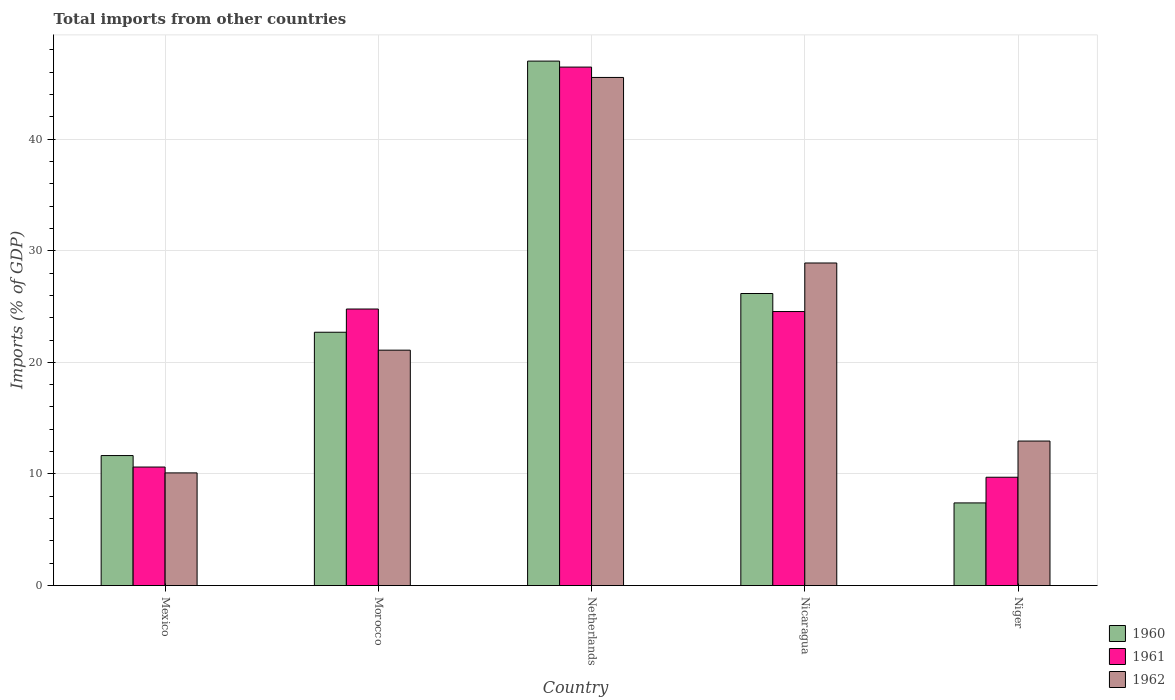How many bars are there on the 4th tick from the left?
Provide a succinct answer. 3. What is the label of the 3rd group of bars from the left?
Ensure brevity in your answer.  Netherlands. What is the total imports in 1961 in Netherlands?
Offer a very short reply. 46.46. Across all countries, what is the maximum total imports in 1961?
Make the answer very short. 46.46. Across all countries, what is the minimum total imports in 1961?
Keep it short and to the point. 9.71. What is the total total imports in 1962 in the graph?
Make the answer very short. 118.57. What is the difference between the total imports in 1960 in Nicaragua and that in Niger?
Provide a short and direct response. 18.76. What is the difference between the total imports in 1960 in Mexico and the total imports in 1962 in Niger?
Keep it short and to the point. -1.3. What is the average total imports in 1962 per country?
Offer a terse response. 23.71. What is the difference between the total imports of/in 1962 and total imports of/in 1961 in Netherlands?
Keep it short and to the point. -0.93. In how many countries, is the total imports in 1960 greater than 12 %?
Keep it short and to the point. 3. What is the ratio of the total imports in 1962 in Morocco to that in Nicaragua?
Provide a succinct answer. 0.73. What is the difference between the highest and the second highest total imports in 1962?
Your answer should be compact. -7.81. What is the difference between the highest and the lowest total imports in 1961?
Give a very brief answer. 36.75. Is the sum of the total imports in 1962 in Morocco and Niger greater than the maximum total imports in 1961 across all countries?
Make the answer very short. No. How many bars are there?
Provide a succinct answer. 15. Are the values on the major ticks of Y-axis written in scientific E-notation?
Your response must be concise. No. Does the graph contain any zero values?
Offer a terse response. No. Does the graph contain grids?
Your answer should be very brief. Yes. How many legend labels are there?
Provide a succinct answer. 3. How are the legend labels stacked?
Provide a succinct answer. Vertical. What is the title of the graph?
Your response must be concise. Total imports from other countries. What is the label or title of the X-axis?
Offer a very short reply. Country. What is the label or title of the Y-axis?
Your answer should be compact. Imports (% of GDP). What is the Imports (% of GDP) in 1960 in Mexico?
Provide a succinct answer. 11.65. What is the Imports (% of GDP) of 1961 in Mexico?
Your answer should be very brief. 10.62. What is the Imports (% of GDP) in 1962 in Mexico?
Offer a very short reply. 10.09. What is the Imports (% of GDP) of 1960 in Morocco?
Offer a very short reply. 22.7. What is the Imports (% of GDP) in 1961 in Morocco?
Ensure brevity in your answer.  24.78. What is the Imports (% of GDP) of 1962 in Morocco?
Provide a short and direct response. 21.09. What is the Imports (% of GDP) in 1960 in Netherlands?
Ensure brevity in your answer.  46.99. What is the Imports (% of GDP) of 1961 in Netherlands?
Provide a succinct answer. 46.46. What is the Imports (% of GDP) in 1962 in Netherlands?
Provide a short and direct response. 45.53. What is the Imports (% of GDP) of 1960 in Nicaragua?
Your answer should be very brief. 26.17. What is the Imports (% of GDP) of 1961 in Nicaragua?
Keep it short and to the point. 24.55. What is the Imports (% of GDP) of 1962 in Nicaragua?
Your answer should be very brief. 28.9. What is the Imports (% of GDP) of 1960 in Niger?
Offer a very short reply. 7.41. What is the Imports (% of GDP) of 1961 in Niger?
Offer a terse response. 9.71. What is the Imports (% of GDP) of 1962 in Niger?
Your response must be concise. 12.95. Across all countries, what is the maximum Imports (% of GDP) of 1960?
Offer a terse response. 46.99. Across all countries, what is the maximum Imports (% of GDP) of 1961?
Offer a terse response. 46.46. Across all countries, what is the maximum Imports (% of GDP) of 1962?
Keep it short and to the point. 45.53. Across all countries, what is the minimum Imports (% of GDP) in 1960?
Offer a terse response. 7.41. Across all countries, what is the minimum Imports (% of GDP) of 1961?
Keep it short and to the point. 9.71. Across all countries, what is the minimum Imports (% of GDP) in 1962?
Make the answer very short. 10.09. What is the total Imports (% of GDP) of 1960 in the graph?
Provide a succinct answer. 114.92. What is the total Imports (% of GDP) of 1961 in the graph?
Give a very brief answer. 116.11. What is the total Imports (% of GDP) in 1962 in the graph?
Offer a very short reply. 118.57. What is the difference between the Imports (% of GDP) of 1960 in Mexico and that in Morocco?
Ensure brevity in your answer.  -11.05. What is the difference between the Imports (% of GDP) in 1961 in Mexico and that in Morocco?
Your answer should be very brief. -14.16. What is the difference between the Imports (% of GDP) of 1962 in Mexico and that in Morocco?
Your response must be concise. -11. What is the difference between the Imports (% of GDP) in 1960 in Mexico and that in Netherlands?
Give a very brief answer. -35.34. What is the difference between the Imports (% of GDP) in 1961 in Mexico and that in Netherlands?
Your answer should be very brief. -35.84. What is the difference between the Imports (% of GDP) in 1962 in Mexico and that in Netherlands?
Offer a terse response. -35.43. What is the difference between the Imports (% of GDP) of 1960 in Mexico and that in Nicaragua?
Keep it short and to the point. -14.52. What is the difference between the Imports (% of GDP) of 1961 in Mexico and that in Nicaragua?
Provide a short and direct response. -13.93. What is the difference between the Imports (% of GDP) of 1962 in Mexico and that in Nicaragua?
Your answer should be very brief. -18.81. What is the difference between the Imports (% of GDP) of 1960 in Mexico and that in Niger?
Your answer should be very brief. 4.24. What is the difference between the Imports (% of GDP) in 1961 in Mexico and that in Niger?
Provide a succinct answer. 0.91. What is the difference between the Imports (% of GDP) in 1962 in Mexico and that in Niger?
Provide a short and direct response. -2.85. What is the difference between the Imports (% of GDP) of 1960 in Morocco and that in Netherlands?
Your answer should be very brief. -24.29. What is the difference between the Imports (% of GDP) in 1961 in Morocco and that in Netherlands?
Your answer should be compact. -21.68. What is the difference between the Imports (% of GDP) in 1962 in Morocco and that in Netherlands?
Make the answer very short. -24.44. What is the difference between the Imports (% of GDP) in 1960 in Morocco and that in Nicaragua?
Offer a terse response. -3.47. What is the difference between the Imports (% of GDP) of 1961 in Morocco and that in Nicaragua?
Ensure brevity in your answer.  0.22. What is the difference between the Imports (% of GDP) in 1962 in Morocco and that in Nicaragua?
Make the answer very short. -7.81. What is the difference between the Imports (% of GDP) of 1960 in Morocco and that in Niger?
Your response must be concise. 15.29. What is the difference between the Imports (% of GDP) in 1961 in Morocco and that in Niger?
Your answer should be very brief. 15.07. What is the difference between the Imports (% of GDP) in 1962 in Morocco and that in Niger?
Ensure brevity in your answer.  8.15. What is the difference between the Imports (% of GDP) in 1960 in Netherlands and that in Nicaragua?
Provide a succinct answer. 20.82. What is the difference between the Imports (% of GDP) in 1961 in Netherlands and that in Nicaragua?
Provide a succinct answer. 21.9. What is the difference between the Imports (% of GDP) in 1962 in Netherlands and that in Nicaragua?
Your answer should be very brief. 16.63. What is the difference between the Imports (% of GDP) in 1960 in Netherlands and that in Niger?
Provide a short and direct response. 39.59. What is the difference between the Imports (% of GDP) in 1961 in Netherlands and that in Niger?
Make the answer very short. 36.75. What is the difference between the Imports (% of GDP) of 1962 in Netherlands and that in Niger?
Your answer should be compact. 32.58. What is the difference between the Imports (% of GDP) of 1960 in Nicaragua and that in Niger?
Your response must be concise. 18.76. What is the difference between the Imports (% of GDP) of 1961 in Nicaragua and that in Niger?
Make the answer very short. 14.85. What is the difference between the Imports (% of GDP) in 1962 in Nicaragua and that in Niger?
Your answer should be compact. 15.96. What is the difference between the Imports (% of GDP) in 1960 in Mexico and the Imports (% of GDP) in 1961 in Morocco?
Make the answer very short. -13.13. What is the difference between the Imports (% of GDP) in 1960 in Mexico and the Imports (% of GDP) in 1962 in Morocco?
Provide a short and direct response. -9.44. What is the difference between the Imports (% of GDP) of 1961 in Mexico and the Imports (% of GDP) of 1962 in Morocco?
Provide a short and direct response. -10.47. What is the difference between the Imports (% of GDP) in 1960 in Mexico and the Imports (% of GDP) in 1961 in Netherlands?
Ensure brevity in your answer.  -34.81. What is the difference between the Imports (% of GDP) in 1960 in Mexico and the Imports (% of GDP) in 1962 in Netherlands?
Your response must be concise. -33.88. What is the difference between the Imports (% of GDP) in 1961 in Mexico and the Imports (% of GDP) in 1962 in Netherlands?
Provide a short and direct response. -34.91. What is the difference between the Imports (% of GDP) in 1960 in Mexico and the Imports (% of GDP) in 1961 in Nicaragua?
Ensure brevity in your answer.  -12.9. What is the difference between the Imports (% of GDP) in 1960 in Mexico and the Imports (% of GDP) in 1962 in Nicaragua?
Your response must be concise. -17.25. What is the difference between the Imports (% of GDP) in 1961 in Mexico and the Imports (% of GDP) in 1962 in Nicaragua?
Provide a short and direct response. -18.28. What is the difference between the Imports (% of GDP) of 1960 in Mexico and the Imports (% of GDP) of 1961 in Niger?
Make the answer very short. 1.94. What is the difference between the Imports (% of GDP) of 1960 in Mexico and the Imports (% of GDP) of 1962 in Niger?
Give a very brief answer. -1.3. What is the difference between the Imports (% of GDP) in 1961 in Mexico and the Imports (% of GDP) in 1962 in Niger?
Offer a terse response. -2.33. What is the difference between the Imports (% of GDP) of 1960 in Morocco and the Imports (% of GDP) of 1961 in Netherlands?
Your answer should be very brief. -23.76. What is the difference between the Imports (% of GDP) in 1960 in Morocco and the Imports (% of GDP) in 1962 in Netherlands?
Give a very brief answer. -22.83. What is the difference between the Imports (% of GDP) of 1961 in Morocco and the Imports (% of GDP) of 1962 in Netherlands?
Give a very brief answer. -20.75. What is the difference between the Imports (% of GDP) of 1960 in Morocco and the Imports (% of GDP) of 1961 in Nicaragua?
Give a very brief answer. -1.85. What is the difference between the Imports (% of GDP) of 1960 in Morocco and the Imports (% of GDP) of 1962 in Nicaragua?
Your response must be concise. -6.2. What is the difference between the Imports (% of GDP) in 1961 in Morocco and the Imports (% of GDP) in 1962 in Nicaragua?
Make the answer very short. -4.13. What is the difference between the Imports (% of GDP) of 1960 in Morocco and the Imports (% of GDP) of 1961 in Niger?
Offer a very short reply. 12.99. What is the difference between the Imports (% of GDP) in 1960 in Morocco and the Imports (% of GDP) in 1962 in Niger?
Your answer should be compact. 9.75. What is the difference between the Imports (% of GDP) in 1961 in Morocco and the Imports (% of GDP) in 1962 in Niger?
Provide a short and direct response. 11.83. What is the difference between the Imports (% of GDP) of 1960 in Netherlands and the Imports (% of GDP) of 1961 in Nicaragua?
Your answer should be compact. 22.44. What is the difference between the Imports (% of GDP) in 1960 in Netherlands and the Imports (% of GDP) in 1962 in Nicaragua?
Offer a very short reply. 18.09. What is the difference between the Imports (% of GDP) of 1961 in Netherlands and the Imports (% of GDP) of 1962 in Nicaragua?
Your answer should be compact. 17.55. What is the difference between the Imports (% of GDP) of 1960 in Netherlands and the Imports (% of GDP) of 1961 in Niger?
Ensure brevity in your answer.  37.29. What is the difference between the Imports (% of GDP) of 1960 in Netherlands and the Imports (% of GDP) of 1962 in Niger?
Your answer should be compact. 34.05. What is the difference between the Imports (% of GDP) in 1961 in Netherlands and the Imports (% of GDP) in 1962 in Niger?
Keep it short and to the point. 33.51. What is the difference between the Imports (% of GDP) in 1960 in Nicaragua and the Imports (% of GDP) in 1961 in Niger?
Your answer should be compact. 16.46. What is the difference between the Imports (% of GDP) of 1960 in Nicaragua and the Imports (% of GDP) of 1962 in Niger?
Ensure brevity in your answer.  13.22. What is the difference between the Imports (% of GDP) of 1961 in Nicaragua and the Imports (% of GDP) of 1962 in Niger?
Offer a very short reply. 11.61. What is the average Imports (% of GDP) in 1960 per country?
Provide a succinct answer. 22.98. What is the average Imports (% of GDP) of 1961 per country?
Offer a very short reply. 23.22. What is the average Imports (% of GDP) in 1962 per country?
Provide a succinct answer. 23.71. What is the difference between the Imports (% of GDP) in 1960 and Imports (% of GDP) in 1961 in Mexico?
Your answer should be very brief. 1.03. What is the difference between the Imports (% of GDP) in 1960 and Imports (% of GDP) in 1962 in Mexico?
Your answer should be compact. 1.55. What is the difference between the Imports (% of GDP) of 1961 and Imports (% of GDP) of 1962 in Mexico?
Your response must be concise. 0.53. What is the difference between the Imports (% of GDP) in 1960 and Imports (% of GDP) in 1961 in Morocco?
Make the answer very short. -2.08. What is the difference between the Imports (% of GDP) of 1960 and Imports (% of GDP) of 1962 in Morocco?
Your answer should be very brief. 1.61. What is the difference between the Imports (% of GDP) of 1961 and Imports (% of GDP) of 1962 in Morocco?
Offer a very short reply. 3.69. What is the difference between the Imports (% of GDP) in 1960 and Imports (% of GDP) in 1961 in Netherlands?
Provide a succinct answer. 0.54. What is the difference between the Imports (% of GDP) of 1960 and Imports (% of GDP) of 1962 in Netherlands?
Offer a terse response. 1.46. What is the difference between the Imports (% of GDP) of 1961 and Imports (% of GDP) of 1962 in Netherlands?
Your answer should be very brief. 0.93. What is the difference between the Imports (% of GDP) of 1960 and Imports (% of GDP) of 1961 in Nicaragua?
Your answer should be very brief. 1.62. What is the difference between the Imports (% of GDP) in 1960 and Imports (% of GDP) in 1962 in Nicaragua?
Make the answer very short. -2.73. What is the difference between the Imports (% of GDP) in 1961 and Imports (% of GDP) in 1962 in Nicaragua?
Offer a terse response. -4.35. What is the difference between the Imports (% of GDP) of 1960 and Imports (% of GDP) of 1962 in Niger?
Keep it short and to the point. -5.54. What is the difference between the Imports (% of GDP) in 1961 and Imports (% of GDP) in 1962 in Niger?
Your answer should be compact. -3.24. What is the ratio of the Imports (% of GDP) of 1960 in Mexico to that in Morocco?
Your answer should be very brief. 0.51. What is the ratio of the Imports (% of GDP) of 1961 in Mexico to that in Morocco?
Give a very brief answer. 0.43. What is the ratio of the Imports (% of GDP) of 1962 in Mexico to that in Morocco?
Keep it short and to the point. 0.48. What is the ratio of the Imports (% of GDP) of 1960 in Mexico to that in Netherlands?
Offer a very short reply. 0.25. What is the ratio of the Imports (% of GDP) in 1961 in Mexico to that in Netherlands?
Offer a terse response. 0.23. What is the ratio of the Imports (% of GDP) in 1962 in Mexico to that in Netherlands?
Offer a terse response. 0.22. What is the ratio of the Imports (% of GDP) of 1960 in Mexico to that in Nicaragua?
Provide a short and direct response. 0.45. What is the ratio of the Imports (% of GDP) in 1961 in Mexico to that in Nicaragua?
Your answer should be very brief. 0.43. What is the ratio of the Imports (% of GDP) of 1962 in Mexico to that in Nicaragua?
Keep it short and to the point. 0.35. What is the ratio of the Imports (% of GDP) of 1960 in Mexico to that in Niger?
Provide a short and direct response. 1.57. What is the ratio of the Imports (% of GDP) in 1961 in Mexico to that in Niger?
Offer a very short reply. 1.09. What is the ratio of the Imports (% of GDP) in 1962 in Mexico to that in Niger?
Provide a succinct answer. 0.78. What is the ratio of the Imports (% of GDP) of 1960 in Morocco to that in Netherlands?
Your response must be concise. 0.48. What is the ratio of the Imports (% of GDP) in 1961 in Morocco to that in Netherlands?
Your answer should be very brief. 0.53. What is the ratio of the Imports (% of GDP) of 1962 in Morocco to that in Netherlands?
Offer a very short reply. 0.46. What is the ratio of the Imports (% of GDP) of 1960 in Morocco to that in Nicaragua?
Your response must be concise. 0.87. What is the ratio of the Imports (% of GDP) in 1961 in Morocco to that in Nicaragua?
Ensure brevity in your answer.  1.01. What is the ratio of the Imports (% of GDP) in 1962 in Morocco to that in Nicaragua?
Keep it short and to the point. 0.73. What is the ratio of the Imports (% of GDP) in 1960 in Morocco to that in Niger?
Ensure brevity in your answer.  3.07. What is the ratio of the Imports (% of GDP) of 1961 in Morocco to that in Niger?
Keep it short and to the point. 2.55. What is the ratio of the Imports (% of GDP) in 1962 in Morocco to that in Niger?
Ensure brevity in your answer.  1.63. What is the ratio of the Imports (% of GDP) of 1960 in Netherlands to that in Nicaragua?
Keep it short and to the point. 1.8. What is the ratio of the Imports (% of GDP) in 1961 in Netherlands to that in Nicaragua?
Your answer should be very brief. 1.89. What is the ratio of the Imports (% of GDP) in 1962 in Netherlands to that in Nicaragua?
Provide a succinct answer. 1.58. What is the ratio of the Imports (% of GDP) of 1960 in Netherlands to that in Niger?
Offer a terse response. 6.35. What is the ratio of the Imports (% of GDP) of 1961 in Netherlands to that in Niger?
Offer a very short reply. 4.79. What is the ratio of the Imports (% of GDP) in 1962 in Netherlands to that in Niger?
Offer a very short reply. 3.52. What is the ratio of the Imports (% of GDP) of 1960 in Nicaragua to that in Niger?
Give a very brief answer. 3.53. What is the ratio of the Imports (% of GDP) in 1961 in Nicaragua to that in Niger?
Your response must be concise. 2.53. What is the ratio of the Imports (% of GDP) of 1962 in Nicaragua to that in Niger?
Make the answer very short. 2.23. What is the difference between the highest and the second highest Imports (% of GDP) of 1960?
Offer a very short reply. 20.82. What is the difference between the highest and the second highest Imports (% of GDP) of 1961?
Offer a terse response. 21.68. What is the difference between the highest and the second highest Imports (% of GDP) in 1962?
Give a very brief answer. 16.63. What is the difference between the highest and the lowest Imports (% of GDP) in 1960?
Make the answer very short. 39.59. What is the difference between the highest and the lowest Imports (% of GDP) in 1961?
Give a very brief answer. 36.75. What is the difference between the highest and the lowest Imports (% of GDP) of 1962?
Make the answer very short. 35.43. 